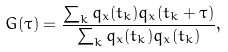<formula> <loc_0><loc_0><loc_500><loc_500>G ( \tau ) = \frac { \sum _ { k } q _ { x } ( t _ { k } ) q _ { x } ( t _ { k } + \tau ) } { \sum _ { k } q _ { x } ( t _ { k } ) q _ { x } ( t _ { k } ) } ,</formula> 